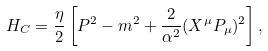<formula> <loc_0><loc_0><loc_500><loc_500>H _ { C } = \frac { \eta } { 2 } \left [ P ^ { 2 } - m ^ { 2 } + \frac { 2 } { \alpha ^ { 2 } } ( X ^ { \mu } P _ { \mu } ) ^ { 2 } \right ] ,</formula> 